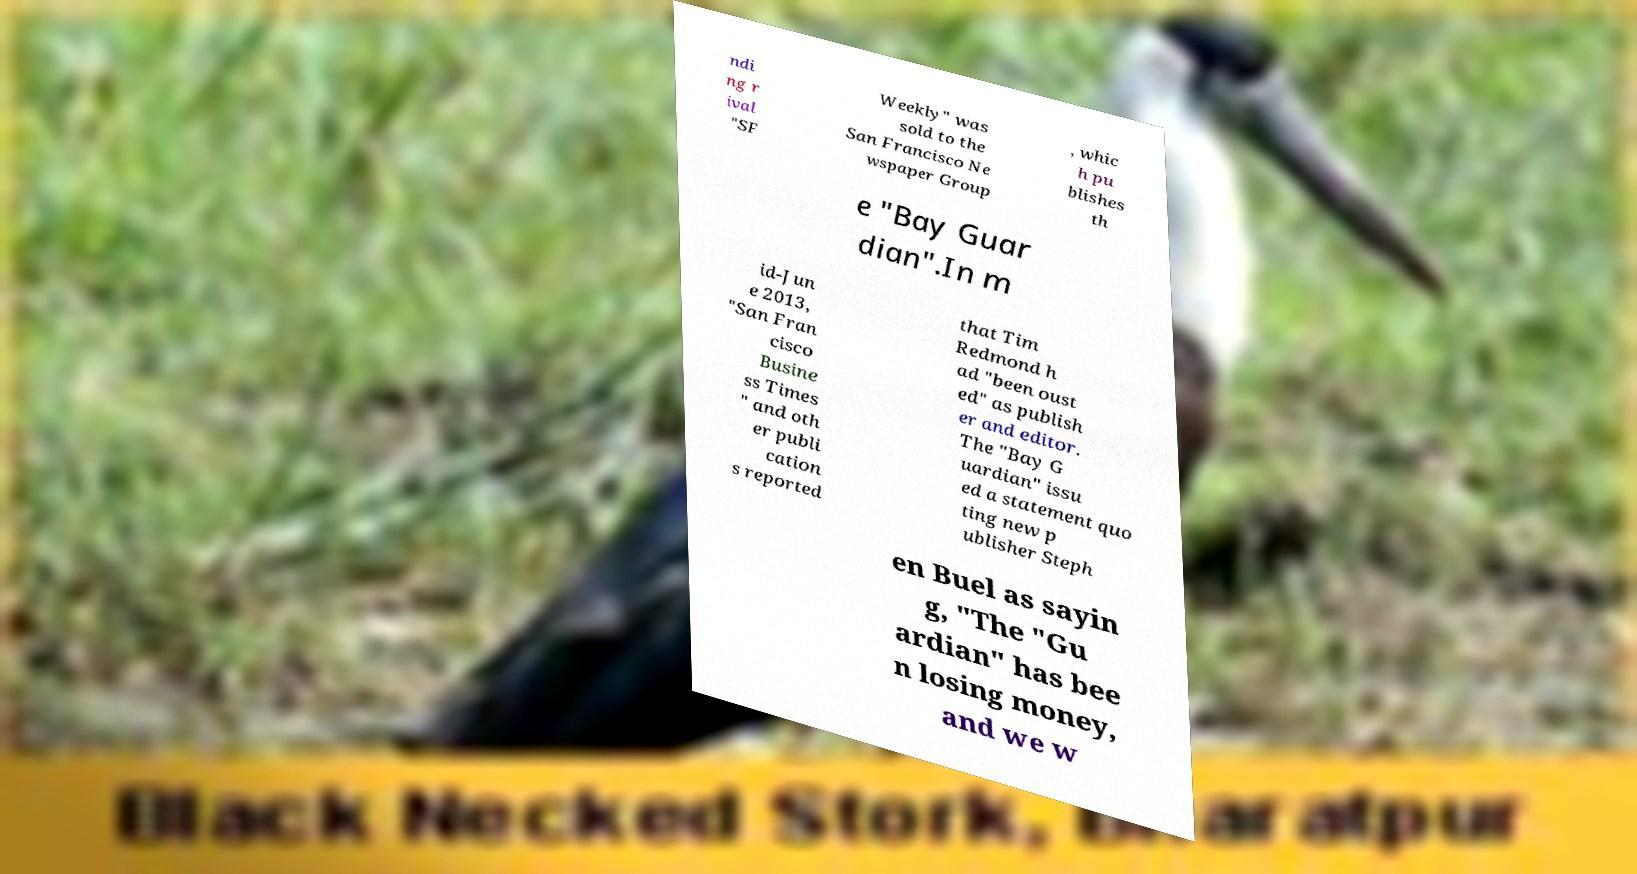What messages or text are displayed in this image? I need them in a readable, typed format. ndi ng r ival "SF Weekly" was sold to the San Francisco Ne wspaper Group , whic h pu blishes th e "Bay Guar dian".In m id-Jun e 2013, "San Fran cisco Busine ss Times " and oth er publi cation s reported that Tim Redmond h ad "been oust ed" as publish er and editor. The "Bay G uardian" issu ed a statement quo ting new p ublisher Steph en Buel as sayin g, "The "Gu ardian" has bee n losing money, and we w 